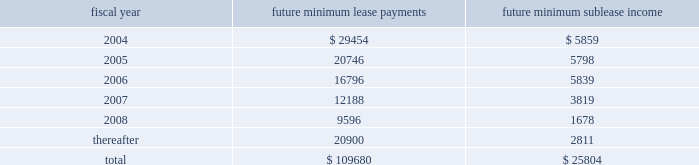Remarketing proceeds and the lease balance , up to the maximum recourse amount of $ 90.8 million ( 201cresidual value guarantee 201d ) .
In august 1999 , we entered into a five-year lease agreement for our other two office buildings that currently serve as our corporate headquarters in san jose , california .
Under the agreement , we have the option to purchase the buildings at any time during the lease term for the lease balance , which is approximately $ 142.5 million .
The lease is subject to standard covenants including liquidity , leverage and profitability ratios that are reported to the lessor quarterly .
As of november 28 , 2003 , we were in compliance with all covenants .
In the case of a default , the lessor may demand we purchase the buildings for an amount equal to the lease balance , or require that we remarket or relinquish the buildings .
The agreement qualifies for operating lease accounting treatment under sfas 13 and , as such , the buildings and the related obligation are not included on our balance sheet .
We utilized this type of financing because it allows us to access bank-provided funding at the most favorable rates and allows us to maintain our cash balances for other corporate purposes .
At the end of the lease term , we can purchase the buildings for the lease balance , remarket or relinquish the buildings .
If we choose to remarket or are required to do so upon relinquishing the buildings , we are bound to arrange the sale of the buildings to an unrelated party and will be required to pay the lessor any shortfall between the net remarketing proceeds and the lease balance , up to the maximum recourse amount of $ 132.6 million ( 201cresidual value guarantee 201d ) .
There were no changes in the agreement or level of obligations from the end of fiscal 2002 .
We are in the process of evaluating alternative financing methods at expiration of the lease in fiscal 2004 and believe that several suitable financing options will be available to us .
As of november 28 , 2003 , future minimum lease payments under noncancelable operating leases and future minimum sublease income under noncancelable subleases are as follows : fiscal year future minimum lease payments future minimum sublease income .
Royalties we have certain royalty commitments associated with the shipment and licensing of certain products .
Royalty expense is generally based on a dollar amount per unit shipped or a percentage of the underlying revenue .
Royalty expense , which was recorded under our cost of products revenue on our consolidated statements of income , was approximately $ 14.5 million , $ 14.4 million and $ 14.1 million in fiscal 2003 , 2002 and 2001 , respectively .
Guarantees we adopted fin 45 at the beginning of our fiscal year 2003 .
See 201cguarantees 201d and 201crecent accounting pronouncements 201d in note 1 of our notes to consolidated financial statements for further information regarding fin 45 .
Legal actions in early 2002 , international typeface corporation ( 201citc 201d ) and agfa monotype corporation ( 201camt 201d ) , companies which have common ownership and management , each charged , by way of informal letters to adobe , that adobe's distribution of font software , which generates itc and amt typefaces , breaches its contracts with itc and amt , respectively , pursuant to which adobe licensed certain rights with respect to itc and amt typefaces .
Amt and itc further charged that adobe violated the digital millennium copyright act ( 201cdmca 201d ) with respect to , or induced or contributed to , the infringement of copyrights in , itc 2019s and amt's truetype font software. .
What is the net cash outflow related to future lease payments in 2005? 
Computations: (20746 - 5798)
Answer: 14948.0. Remarketing proceeds and the lease balance , up to the maximum recourse amount of $ 90.8 million ( 201cresidual value guarantee 201d ) .
In august 1999 , we entered into a five-year lease agreement for our other two office buildings that currently serve as our corporate headquarters in san jose , california .
Under the agreement , we have the option to purchase the buildings at any time during the lease term for the lease balance , which is approximately $ 142.5 million .
The lease is subject to standard covenants including liquidity , leverage and profitability ratios that are reported to the lessor quarterly .
As of november 28 , 2003 , we were in compliance with all covenants .
In the case of a default , the lessor may demand we purchase the buildings for an amount equal to the lease balance , or require that we remarket or relinquish the buildings .
The agreement qualifies for operating lease accounting treatment under sfas 13 and , as such , the buildings and the related obligation are not included on our balance sheet .
We utilized this type of financing because it allows us to access bank-provided funding at the most favorable rates and allows us to maintain our cash balances for other corporate purposes .
At the end of the lease term , we can purchase the buildings for the lease balance , remarket or relinquish the buildings .
If we choose to remarket or are required to do so upon relinquishing the buildings , we are bound to arrange the sale of the buildings to an unrelated party and will be required to pay the lessor any shortfall between the net remarketing proceeds and the lease balance , up to the maximum recourse amount of $ 132.6 million ( 201cresidual value guarantee 201d ) .
There were no changes in the agreement or level of obligations from the end of fiscal 2002 .
We are in the process of evaluating alternative financing methods at expiration of the lease in fiscal 2004 and believe that several suitable financing options will be available to us .
As of november 28 , 2003 , future minimum lease payments under noncancelable operating leases and future minimum sublease income under noncancelable subleases are as follows : fiscal year future minimum lease payments future minimum sublease income .
Royalties we have certain royalty commitments associated with the shipment and licensing of certain products .
Royalty expense is generally based on a dollar amount per unit shipped or a percentage of the underlying revenue .
Royalty expense , which was recorded under our cost of products revenue on our consolidated statements of income , was approximately $ 14.5 million , $ 14.4 million and $ 14.1 million in fiscal 2003 , 2002 and 2001 , respectively .
Guarantees we adopted fin 45 at the beginning of our fiscal year 2003 .
See 201cguarantees 201d and 201crecent accounting pronouncements 201d in note 1 of our notes to consolidated financial statements for further information regarding fin 45 .
Legal actions in early 2002 , international typeface corporation ( 201citc 201d ) and agfa monotype corporation ( 201camt 201d ) , companies which have common ownership and management , each charged , by way of informal letters to adobe , that adobe's distribution of font software , which generates itc and amt typefaces , breaches its contracts with itc and amt , respectively , pursuant to which adobe licensed certain rights with respect to itc and amt typefaces .
Amt and itc further charged that adobe violated the digital millennium copyright act ( 201cdmca 201d ) with respect to , or induced or contributed to , the infringement of copyrights in , itc 2019s and amt's truetype font software. .
For fiscal year 2004 , what was the difference between future minimum lease payments and future minimum sublease income , in millions? 
Computations: (29454 - 5859)
Answer: 23595.0. 